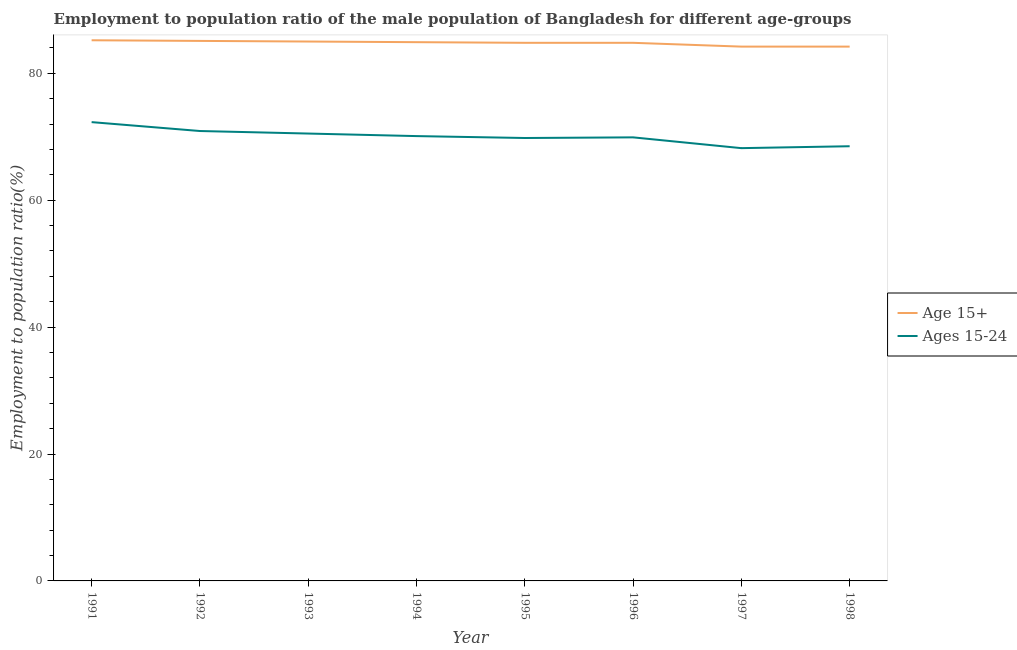How many different coloured lines are there?
Offer a terse response. 2. Is the number of lines equal to the number of legend labels?
Keep it short and to the point. Yes. What is the employment to population ratio(age 15+) in 1992?
Provide a succinct answer. 85.1. Across all years, what is the maximum employment to population ratio(age 15+)?
Your answer should be very brief. 85.2. Across all years, what is the minimum employment to population ratio(age 15-24)?
Your answer should be very brief. 68.2. In which year was the employment to population ratio(age 15-24) maximum?
Offer a terse response. 1991. What is the total employment to population ratio(age 15+) in the graph?
Your answer should be very brief. 678.2. What is the difference between the employment to population ratio(age 15+) in 1993 and that in 1996?
Provide a short and direct response. 0.2. What is the difference between the employment to population ratio(age 15+) in 1994 and the employment to population ratio(age 15-24) in 1998?
Your response must be concise. 16.4. What is the average employment to population ratio(age 15-24) per year?
Your answer should be compact. 70.03. In the year 1998, what is the difference between the employment to population ratio(age 15+) and employment to population ratio(age 15-24)?
Your response must be concise. 15.7. What is the ratio of the employment to population ratio(age 15-24) in 1997 to that in 1998?
Provide a succinct answer. 1. What is the difference between the highest and the second highest employment to population ratio(age 15-24)?
Make the answer very short. 1.4. What is the difference between the highest and the lowest employment to population ratio(age 15-24)?
Offer a terse response. 4.1. In how many years, is the employment to population ratio(age 15+) greater than the average employment to population ratio(age 15+) taken over all years?
Your answer should be compact. 6. Does the employment to population ratio(age 15+) monotonically increase over the years?
Keep it short and to the point. No. Is the employment to population ratio(age 15+) strictly greater than the employment to population ratio(age 15-24) over the years?
Give a very brief answer. Yes. How many lines are there?
Provide a short and direct response. 2. How many legend labels are there?
Give a very brief answer. 2. What is the title of the graph?
Offer a terse response. Employment to population ratio of the male population of Bangladesh for different age-groups. What is the label or title of the X-axis?
Make the answer very short. Year. What is the label or title of the Y-axis?
Provide a succinct answer. Employment to population ratio(%). What is the Employment to population ratio(%) in Age 15+ in 1991?
Provide a succinct answer. 85.2. What is the Employment to population ratio(%) in Ages 15-24 in 1991?
Make the answer very short. 72.3. What is the Employment to population ratio(%) in Age 15+ in 1992?
Your response must be concise. 85.1. What is the Employment to population ratio(%) of Ages 15-24 in 1992?
Ensure brevity in your answer.  70.9. What is the Employment to population ratio(%) in Ages 15-24 in 1993?
Offer a very short reply. 70.5. What is the Employment to population ratio(%) of Age 15+ in 1994?
Provide a succinct answer. 84.9. What is the Employment to population ratio(%) in Ages 15-24 in 1994?
Offer a terse response. 70.1. What is the Employment to population ratio(%) of Age 15+ in 1995?
Provide a succinct answer. 84.8. What is the Employment to population ratio(%) of Ages 15-24 in 1995?
Offer a terse response. 69.8. What is the Employment to population ratio(%) of Age 15+ in 1996?
Provide a short and direct response. 84.8. What is the Employment to population ratio(%) of Ages 15-24 in 1996?
Your answer should be very brief. 69.9. What is the Employment to population ratio(%) in Age 15+ in 1997?
Offer a very short reply. 84.2. What is the Employment to population ratio(%) in Ages 15-24 in 1997?
Provide a succinct answer. 68.2. What is the Employment to population ratio(%) in Age 15+ in 1998?
Ensure brevity in your answer.  84.2. What is the Employment to population ratio(%) of Ages 15-24 in 1998?
Your answer should be compact. 68.5. Across all years, what is the maximum Employment to population ratio(%) in Age 15+?
Give a very brief answer. 85.2. Across all years, what is the maximum Employment to population ratio(%) in Ages 15-24?
Provide a short and direct response. 72.3. Across all years, what is the minimum Employment to population ratio(%) in Age 15+?
Give a very brief answer. 84.2. Across all years, what is the minimum Employment to population ratio(%) of Ages 15-24?
Give a very brief answer. 68.2. What is the total Employment to population ratio(%) in Age 15+ in the graph?
Your answer should be very brief. 678.2. What is the total Employment to population ratio(%) in Ages 15-24 in the graph?
Provide a succinct answer. 560.2. What is the difference between the Employment to population ratio(%) in Age 15+ in 1991 and that in 1992?
Your answer should be compact. 0.1. What is the difference between the Employment to population ratio(%) in Ages 15-24 in 1991 and that in 1992?
Ensure brevity in your answer.  1.4. What is the difference between the Employment to population ratio(%) in Age 15+ in 1991 and that in 1996?
Ensure brevity in your answer.  0.4. What is the difference between the Employment to population ratio(%) in Ages 15-24 in 1991 and that in 1997?
Provide a short and direct response. 4.1. What is the difference between the Employment to population ratio(%) of Age 15+ in 1991 and that in 1998?
Provide a short and direct response. 1. What is the difference between the Employment to population ratio(%) in Ages 15-24 in 1992 and that in 1993?
Your response must be concise. 0.4. What is the difference between the Employment to population ratio(%) of Age 15+ in 1992 and that in 1995?
Offer a very short reply. 0.3. What is the difference between the Employment to population ratio(%) of Ages 15-24 in 1992 and that in 1995?
Your answer should be very brief. 1.1. What is the difference between the Employment to population ratio(%) in Age 15+ in 1992 and that in 1996?
Keep it short and to the point. 0.3. What is the difference between the Employment to population ratio(%) in Ages 15-24 in 1992 and that in 1996?
Your response must be concise. 1. What is the difference between the Employment to population ratio(%) in Ages 15-24 in 1992 and that in 1997?
Keep it short and to the point. 2.7. What is the difference between the Employment to population ratio(%) of Age 15+ in 1993 and that in 1995?
Give a very brief answer. 0.2. What is the difference between the Employment to population ratio(%) in Ages 15-24 in 1993 and that in 1995?
Make the answer very short. 0.7. What is the difference between the Employment to population ratio(%) in Age 15+ in 1993 and that in 1996?
Your response must be concise. 0.2. What is the difference between the Employment to population ratio(%) of Ages 15-24 in 1993 and that in 1996?
Provide a succinct answer. 0.6. What is the difference between the Employment to population ratio(%) of Age 15+ in 1994 and that in 1995?
Your answer should be compact. 0.1. What is the difference between the Employment to population ratio(%) in Ages 15-24 in 1994 and that in 1997?
Give a very brief answer. 1.9. What is the difference between the Employment to population ratio(%) of Ages 15-24 in 1994 and that in 1998?
Provide a short and direct response. 1.6. What is the difference between the Employment to population ratio(%) in Ages 15-24 in 1995 and that in 1996?
Your answer should be very brief. -0.1. What is the difference between the Employment to population ratio(%) of Ages 15-24 in 1995 and that in 1997?
Give a very brief answer. 1.6. What is the difference between the Employment to population ratio(%) of Ages 15-24 in 1996 and that in 1997?
Offer a very short reply. 1.7. What is the difference between the Employment to population ratio(%) in Age 15+ in 1997 and that in 1998?
Keep it short and to the point. 0. What is the difference between the Employment to population ratio(%) in Ages 15-24 in 1997 and that in 1998?
Ensure brevity in your answer.  -0.3. What is the difference between the Employment to population ratio(%) in Age 15+ in 1991 and the Employment to population ratio(%) in Ages 15-24 in 1993?
Make the answer very short. 14.7. What is the difference between the Employment to population ratio(%) in Age 15+ in 1991 and the Employment to population ratio(%) in Ages 15-24 in 1996?
Offer a very short reply. 15.3. What is the difference between the Employment to population ratio(%) of Age 15+ in 1991 and the Employment to population ratio(%) of Ages 15-24 in 1997?
Provide a succinct answer. 17. What is the difference between the Employment to population ratio(%) of Age 15+ in 1991 and the Employment to population ratio(%) of Ages 15-24 in 1998?
Make the answer very short. 16.7. What is the difference between the Employment to population ratio(%) of Age 15+ in 1992 and the Employment to population ratio(%) of Ages 15-24 in 1993?
Provide a succinct answer. 14.6. What is the difference between the Employment to population ratio(%) of Age 15+ in 1993 and the Employment to population ratio(%) of Ages 15-24 in 1995?
Keep it short and to the point. 15.2. What is the difference between the Employment to population ratio(%) in Age 15+ in 1994 and the Employment to population ratio(%) in Ages 15-24 in 1997?
Your answer should be very brief. 16.7. What is the difference between the Employment to population ratio(%) in Age 15+ in 1995 and the Employment to population ratio(%) in Ages 15-24 in 1997?
Offer a terse response. 16.6. What is the difference between the Employment to population ratio(%) of Age 15+ in 1995 and the Employment to population ratio(%) of Ages 15-24 in 1998?
Your answer should be compact. 16.3. What is the difference between the Employment to population ratio(%) of Age 15+ in 1996 and the Employment to population ratio(%) of Ages 15-24 in 1998?
Your response must be concise. 16.3. What is the average Employment to population ratio(%) of Age 15+ per year?
Ensure brevity in your answer.  84.78. What is the average Employment to population ratio(%) in Ages 15-24 per year?
Provide a short and direct response. 70.03. In the year 1991, what is the difference between the Employment to population ratio(%) in Age 15+ and Employment to population ratio(%) in Ages 15-24?
Provide a succinct answer. 12.9. In the year 1993, what is the difference between the Employment to population ratio(%) in Age 15+ and Employment to population ratio(%) in Ages 15-24?
Give a very brief answer. 14.5. In the year 1994, what is the difference between the Employment to population ratio(%) in Age 15+ and Employment to population ratio(%) in Ages 15-24?
Provide a succinct answer. 14.8. In the year 1995, what is the difference between the Employment to population ratio(%) in Age 15+ and Employment to population ratio(%) in Ages 15-24?
Offer a terse response. 15. What is the ratio of the Employment to population ratio(%) of Ages 15-24 in 1991 to that in 1992?
Offer a terse response. 1.02. What is the ratio of the Employment to population ratio(%) in Age 15+ in 1991 to that in 1993?
Make the answer very short. 1. What is the ratio of the Employment to population ratio(%) of Ages 15-24 in 1991 to that in 1993?
Provide a succinct answer. 1.03. What is the ratio of the Employment to population ratio(%) in Ages 15-24 in 1991 to that in 1994?
Your answer should be very brief. 1.03. What is the ratio of the Employment to population ratio(%) of Age 15+ in 1991 to that in 1995?
Your response must be concise. 1. What is the ratio of the Employment to population ratio(%) of Ages 15-24 in 1991 to that in 1995?
Provide a short and direct response. 1.04. What is the ratio of the Employment to population ratio(%) of Ages 15-24 in 1991 to that in 1996?
Keep it short and to the point. 1.03. What is the ratio of the Employment to population ratio(%) of Age 15+ in 1991 to that in 1997?
Give a very brief answer. 1.01. What is the ratio of the Employment to population ratio(%) of Ages 15-24 in 1991 to that in 1997?
Make the answer very short. 1.06. What is the ratio of the Employment to population ratio(%) in Age 15+ in 1991 to that in 1998?
Your answer should be very brief. 1.01. What is the ratio of the Employment to population ratio(%) in Ages 15-24 in 1991 to that in 1998?
Ensure brevity in your answer.  1.06. What is the ratio of the Employment to population ratio(%) in Age 15+ in 1992 to that in 1993?
Ensure brevity in your answer.  1. What is the ratio of the Employment to population ratio(%) in Age 15+ in 1992 to that in 1994?
Give a very brief answer. 1. What is the ratio of the Employment to population ratio(%) in Ages 15-24 in 1992 to that in 1994?
Your response must be concise. 1.01. What is the ratio of the Employment to population ratio(%) in Ages 15-24 in 1992 to that in 1995?
Ensure brevity in your answer.  1.02. What is the ratio of the Employment to population ratio(%) of Ages 15-24 in 1992 to that in 1996?
Ensure brevity in your answer.  1.01. What is the ratio of the Employment to population ratio(%) of Age 15+ in 1992 to that in 1997?
Keep it short and to the point. 1.01. What is the ratio of the Employment to population ratio(%) in Ages 15-24 in 1992 to that in 1997?
Offer a terse response. 1.04. What is the ratio of the Employment to population ratio(%) of Age 15+ in 1992 to that in 1998?
Provide a short and direct response. 1.01. What is the ratio of the Employment to population ratio(%) of Ages 15-24 in 1992 to that in 1998?
Offer a terse response. 1.03. What is the ratio of the Employment to population ratio(%) in Age 15+ in 1993 to that in 1994?
Ensure brevity in your answer.  1. What is the ratio of the Employment to population ratio(%) of Ages 15-24 in 1993 to that in 1995?
Offer a terse response. 1.01. What is the ratio of the Employment to population ratio(%) of Ages 15-24 in 1993 to that in 1996?
Your answer should be compact. 1.01. What is the ratio of the Employment to population ratio(%) in Age 15+ in 1993 to that in 1997?
Your answer should be very brief. 1.01. What is the ratio of the Employment to population ratio(%) of Ages 15-24 in 1993 to that in 1997?
Offer a terse response. 1.03. What is the ratio of the Employment to population ratio(%) in Age 15+ in 1993 to that in 1998?
Provide a succinct answer. 1.01. What is the ratio of the Employment to population ratio(%) of Ages 15-24 in 1993 to that in 1998?
Offer a terse response. 1.03. What is the ratio of the Employment to population ratio(%) in Ages 15-24 in 1994 to that in 1995?
Give a very brief answer. 1. What is the ratio of the Employment to population ratio(%) of Age 15+ in 1994 to that in 1996?
Your answer should be compact. 1. What is the ratio of the Employment to population ratio(%) in Age 15+ in 1994 to that in 1997?
Provide a short and direct response. 1.01. What is the ratio of the Employment to population ratio(%) of Ages 15-24 in 1994 to that in 1997?
Your answer should be compact. 1.03. What is the ratio of the Employment to population ratio(%) of Age 15+ in 1994 to that in 1998?
Keep it short and to the point. 1.01. What is the ratio of the Employment to population ratio(%) of Ages 15-24 in 1994 to that in 1998?
Your response must be concise. 1.02. What is the ratio of the Employment to population ratio(%) in Age 15+ in 1995 to that in 1996?
Your answer should be compact. 1. What is the ratio of the Employment to population ratio(%) of Ages 15-24 in 1995 to that in 1996?
Your response must be concise. 1. What is the ratio of the Employment to population ratio(%) of Age 15+ in 1995 to that in 1997?
Offer a terse response. 1.01. What is the ratio of the Employment to population ratio(%) of Ages 15-24 in 1995 to that in 1997?
Offer a terse response. 1.02. What is the ratio of the Employment to population ratio(%) of Age 15+ in 1995 to that in 1998?
Your answer should be compact. 1.01. What is the ratio of the Employment to population ratio(%) of Age 15+ in 1996 to that in 1997?
Your response must be concise. 1.01. What is the ratio of the Employment to population ratio(%) of Ages 15-24 in 1996 to that in 1997?
Offer a terse response. 1.02. What is the ratio of the Employment to population ratio(%) in Age 15+ in 1996 to that in 1998?
Provide a short and direct response. 1.01. What is the ratio of the Employment to population ratio(%) of Ages 15-24 in 1996 to that in 1998?
Keep it short and to the point. 1.02. What is the ratio of the Employment to population ratio(%) of Age 15+ in 1997 to that in 1998?
Ensure brevity in your answer.  1. What is the difference between the highest and the second highest Employment to population ratio(%) of Ages 15-24?
Ensure brevity in your answer.  1.4. What is the difference between the highest and the lowest Employment to population ratio(%) in Age 15+?
Keep it short and to the point. 1. 